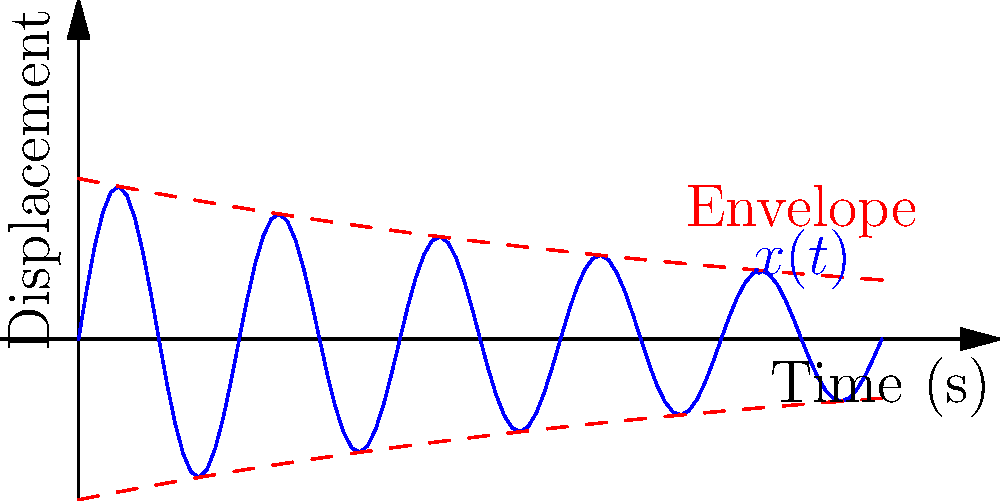As a software engineer working on an open-source project for vibration analysis, you need to implement a function to calculate the natural frequency of a damped spring-mass system. Given a system with mass $m = 2$ kg, spring constant $k = 200$ N/m, and damping coefficient $c = 8$ Ns/m, determine the natural frequency of the system in Hz. The graph shows the displacement $x(t)$ of the system over time. How would you calculate this value programmatically? To calculate the natural frequency of a damped spring-mass system, we need to follow these steps:

1. Calculate the undamped natural frequency $\omega_n$:
   $$\omega_n = \sqrt{\frac{k}{m}}$$
   
2. Calculate the damping ratio $\zeta$:
   $$\zeta = \frac{c}{2\sqrt{km}}$$
   
3. Calculate the damped natural frequency $\omega_d$:
   $$\omega_d = \omega_n\sqrt{1 - \zeta^2}$$
   
4. Convert the angular frequency to Hz:
   $$f_d = \frac{\omega_d}{2\pi}$$

Let's apply these steps to our system:

1. $\omega_n = \sqrt{\frac{200}{2}} = 10$ rad/s

2. $\zeta = \frac{8}{2\sqrt{200 \cdot 2}} = 0.2$

3. $\omega_d = 10\sqrt{1 - 0.2^2} = 9.798$ rad/s

4. $f_d = \frac{9.798}{2\pi} = 1.559$ Hz

To implement this programmatically, you would create a function that takes $m$, $k$, and $c$ as inputs and returns the natural frequency in Hz using these formulas.
Answer: 1.559 Hz 